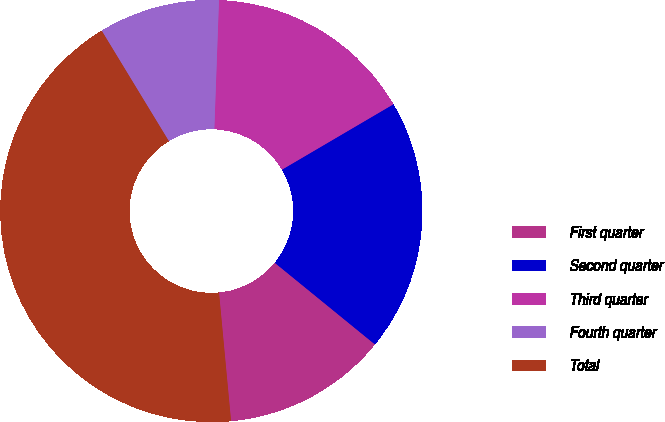<chart> <loc_0><loc_0><loc_500><loc_500><pie_chart><fcel>First quarter<fcel>Second quarter<fcel>Third quarter<fcel>Fourth quarter<fcel>Total<nl><fcel>12.63%<fcel>19.33%<fcel>15.98%<fcel>9.27%<fcel>42.79%<nl></chart> 